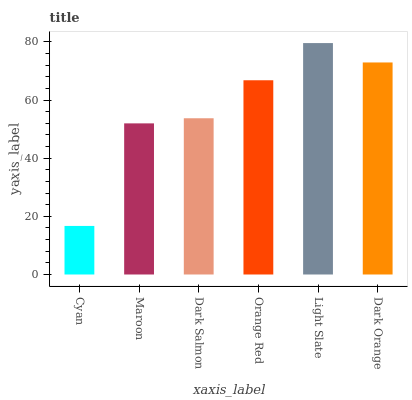Is Cyan the minimum?
Answer yes or no. Yes. Is Light Slate the maximum?
Answer yes or no. Yes. Is Maroon the minimum?
Answer yes or no. No. Is Maroon the maximum?
Answer yes or no. No. Is Maroon greater than Cyan?
Answer yes or no. Yes. Is Cyan less than Maroon?
Answer yes or no. Yes. Is Cyan greater than Maroon?
Answer yes or no. No. Is Maroon less than Cyan?
Answer yes or no. No. Is Orange Red the high median?
Answer yes or no. Yes. Is Dark Salmon the low median?
Answer yes or no. Yes. Is Light Slate the high median?
Answer yes or no. No. Is Orange Red the low median?
Answer yes or no. No. 